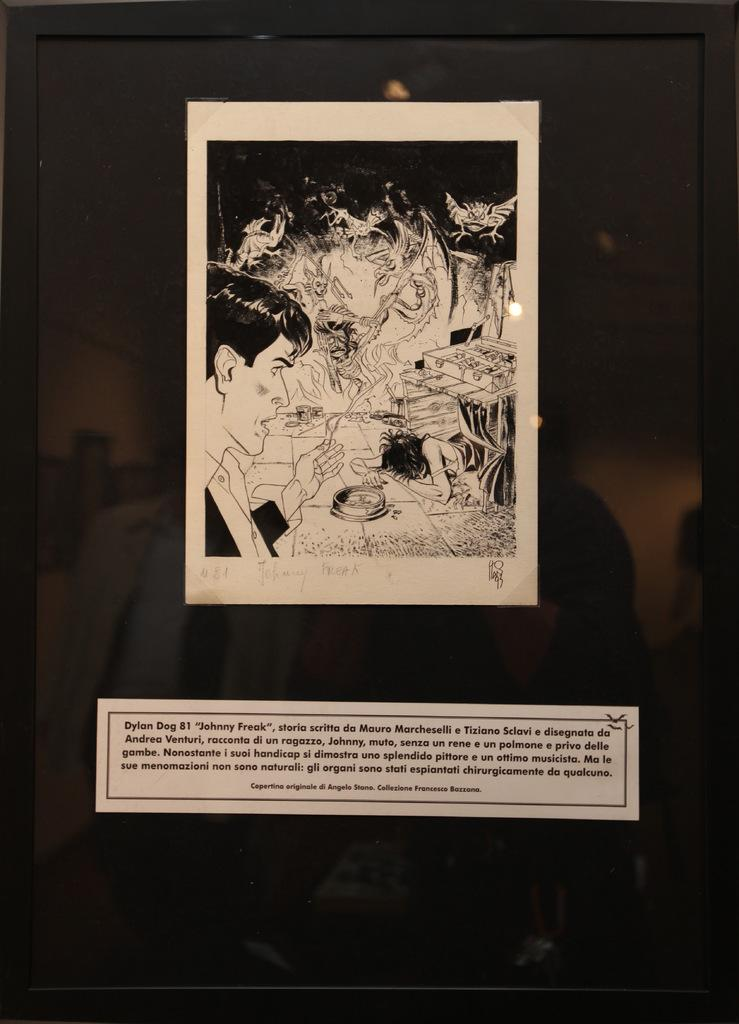Provide a one-sentence caption for the provided image. Photo of a picture in a frame of Dylan Dog. 